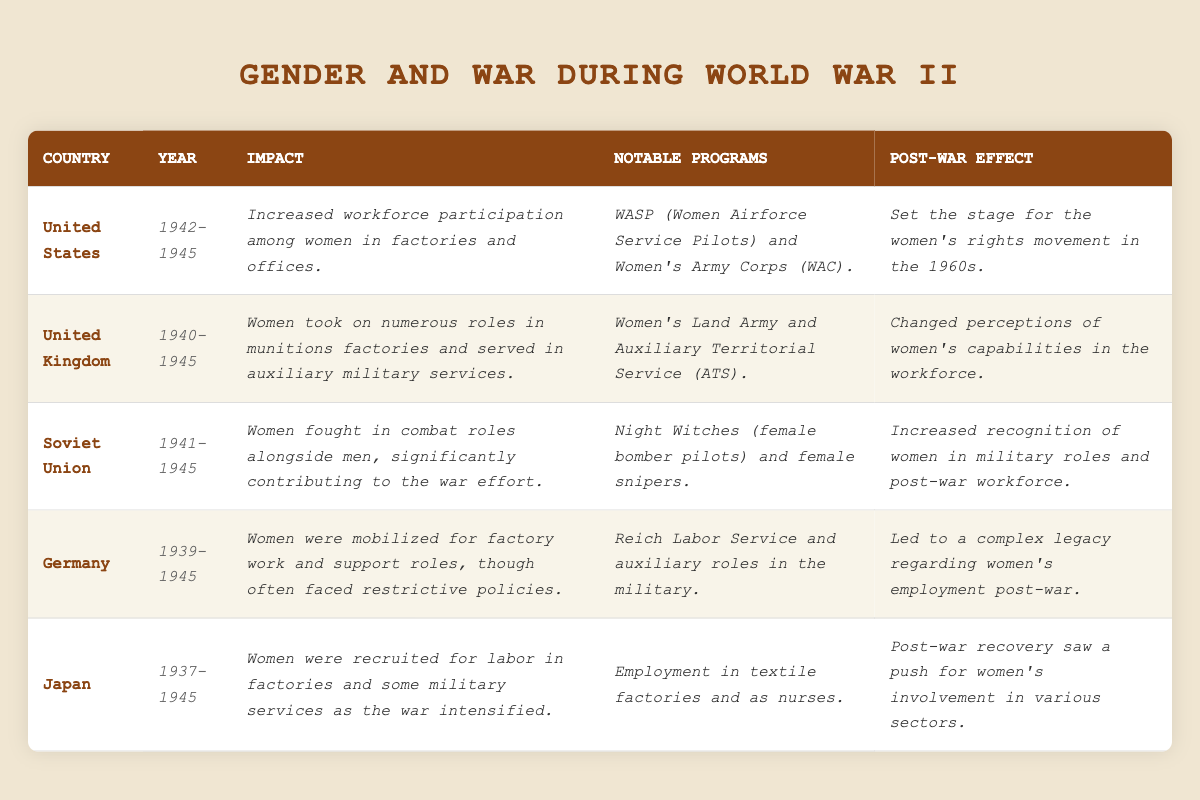What was the impact of World War II on women's workforce participation in the United States? The table states that the impact was increased workforce participation among women in factories and offices from 1942 to 1945.
Answer: Increased workforce participation What notable programs supported women's roles in the United Kingdom during the war? According to the table, notable programs included the Women's Land Army and Auxiliary Territorial Service (ATS).
Answer: Women's Land Army and ATS Did women serve in combat roles in the Soviet Union during World War II? The table indicates that women fought in combat roles alongside men, confirming that they did serve in combat.
Answer: Yes Which country had a post-war effect of changing perceptions of women’s capabilities in the workforce? The table shows that the United Kingdom experienced a change in perceptions regarding women’s capabilities post-war.
Answer: United Kingdom What years did women in Germany primarily support the war effort? The table lists 1939 to 1945 as the years when women in Germany were mobilized for factory work and support roles.
Answer: 1939-1945 How did the contributions of women in the Soviet Union during WWII compare with those in Germany? Women in the Soviet Union fought in combat roles and were significantly recognized, while German women were mobilized for support roles but faced more restrictions; thus, the Soviet experience was more impactful.
Answer: More impactful in the Soviet Union What was stated about Japan's women in the workforce during WWII? The table indicates that Japanese women were recruited for labor in factories and some military services as the war intensified from 1937 to 1945.
Answer: Recruited for labor and military services How did the post-war effects differ between women's roles in the United States and Germany? The post-war effect in the U.S. set the stage for the women's rights movement in the 1960s, while Germany's legacy was complex regarding women's employment; thus, the effects were focused on rights vs. complexity in legacy.
Answer: Focused on rights in the U.S., complexity in Germany What notable programs did women in the Soviet Union participate in during the war? The table lists Night Witches (female bomber pilots) and female snipers as notable programs for women in the Soviet Union.
Answer: Night Witches and female snipers Which country had women predominantly work in munitions factories during World War II? The United Kingdom is noted for having women take on numerous roles in munitions factories during the specified years.
Answer: United Kingdom 